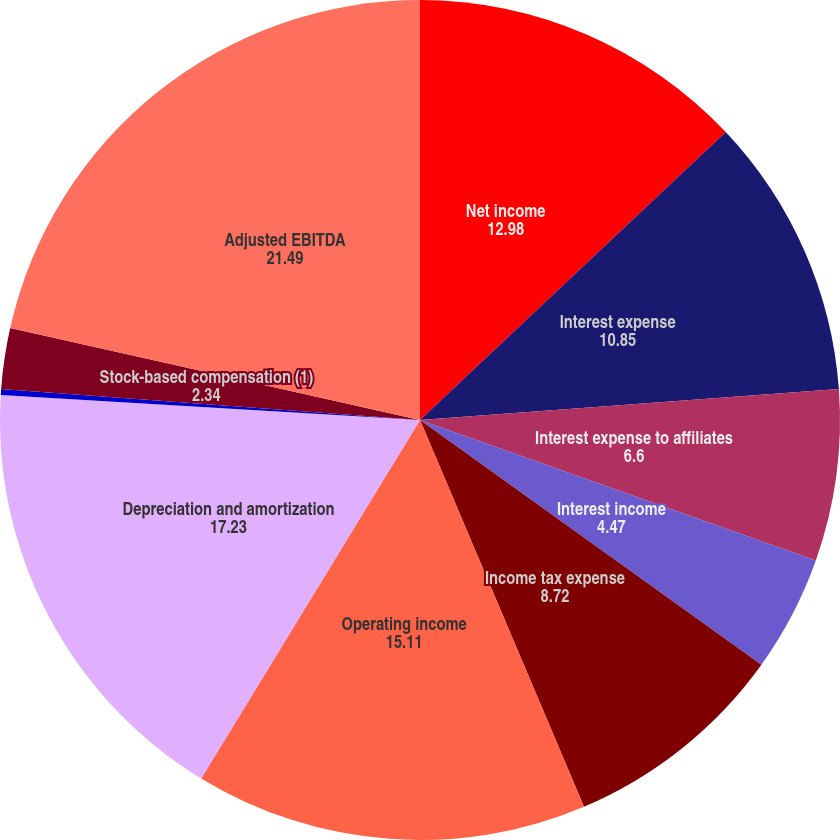<chart> <loc_0><loc_0><loc_500><loc_500><pie_chart><fcel>Net income<fcel>Interest expense<fcel>Interest expense to affiliates<fcel>Interest income<fcel>Income tax expense<fcel>Operating income<fcel>Depreciation and amortization<fcel>Cost of MetroPCS business<fcel>Stock-based compensation (1)<fcel>Adjusted EBITDA<nl><fcel>12.98%<fcel>10.85%<fcel>6.6%<fcel>4.47%<fcel>8.72%<fcel>15.11%<fcel>17.23%<fcel>0.22%<fcel>2.34%<fcel>21.49%<nl></chart> 